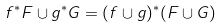<formula> <loc_0><loc_0><loc_500><loc_500>f ^ { * } F \cup g ^ { * } G = ( f \cup g ) ^ { * } ( F \cup G )</formula> 